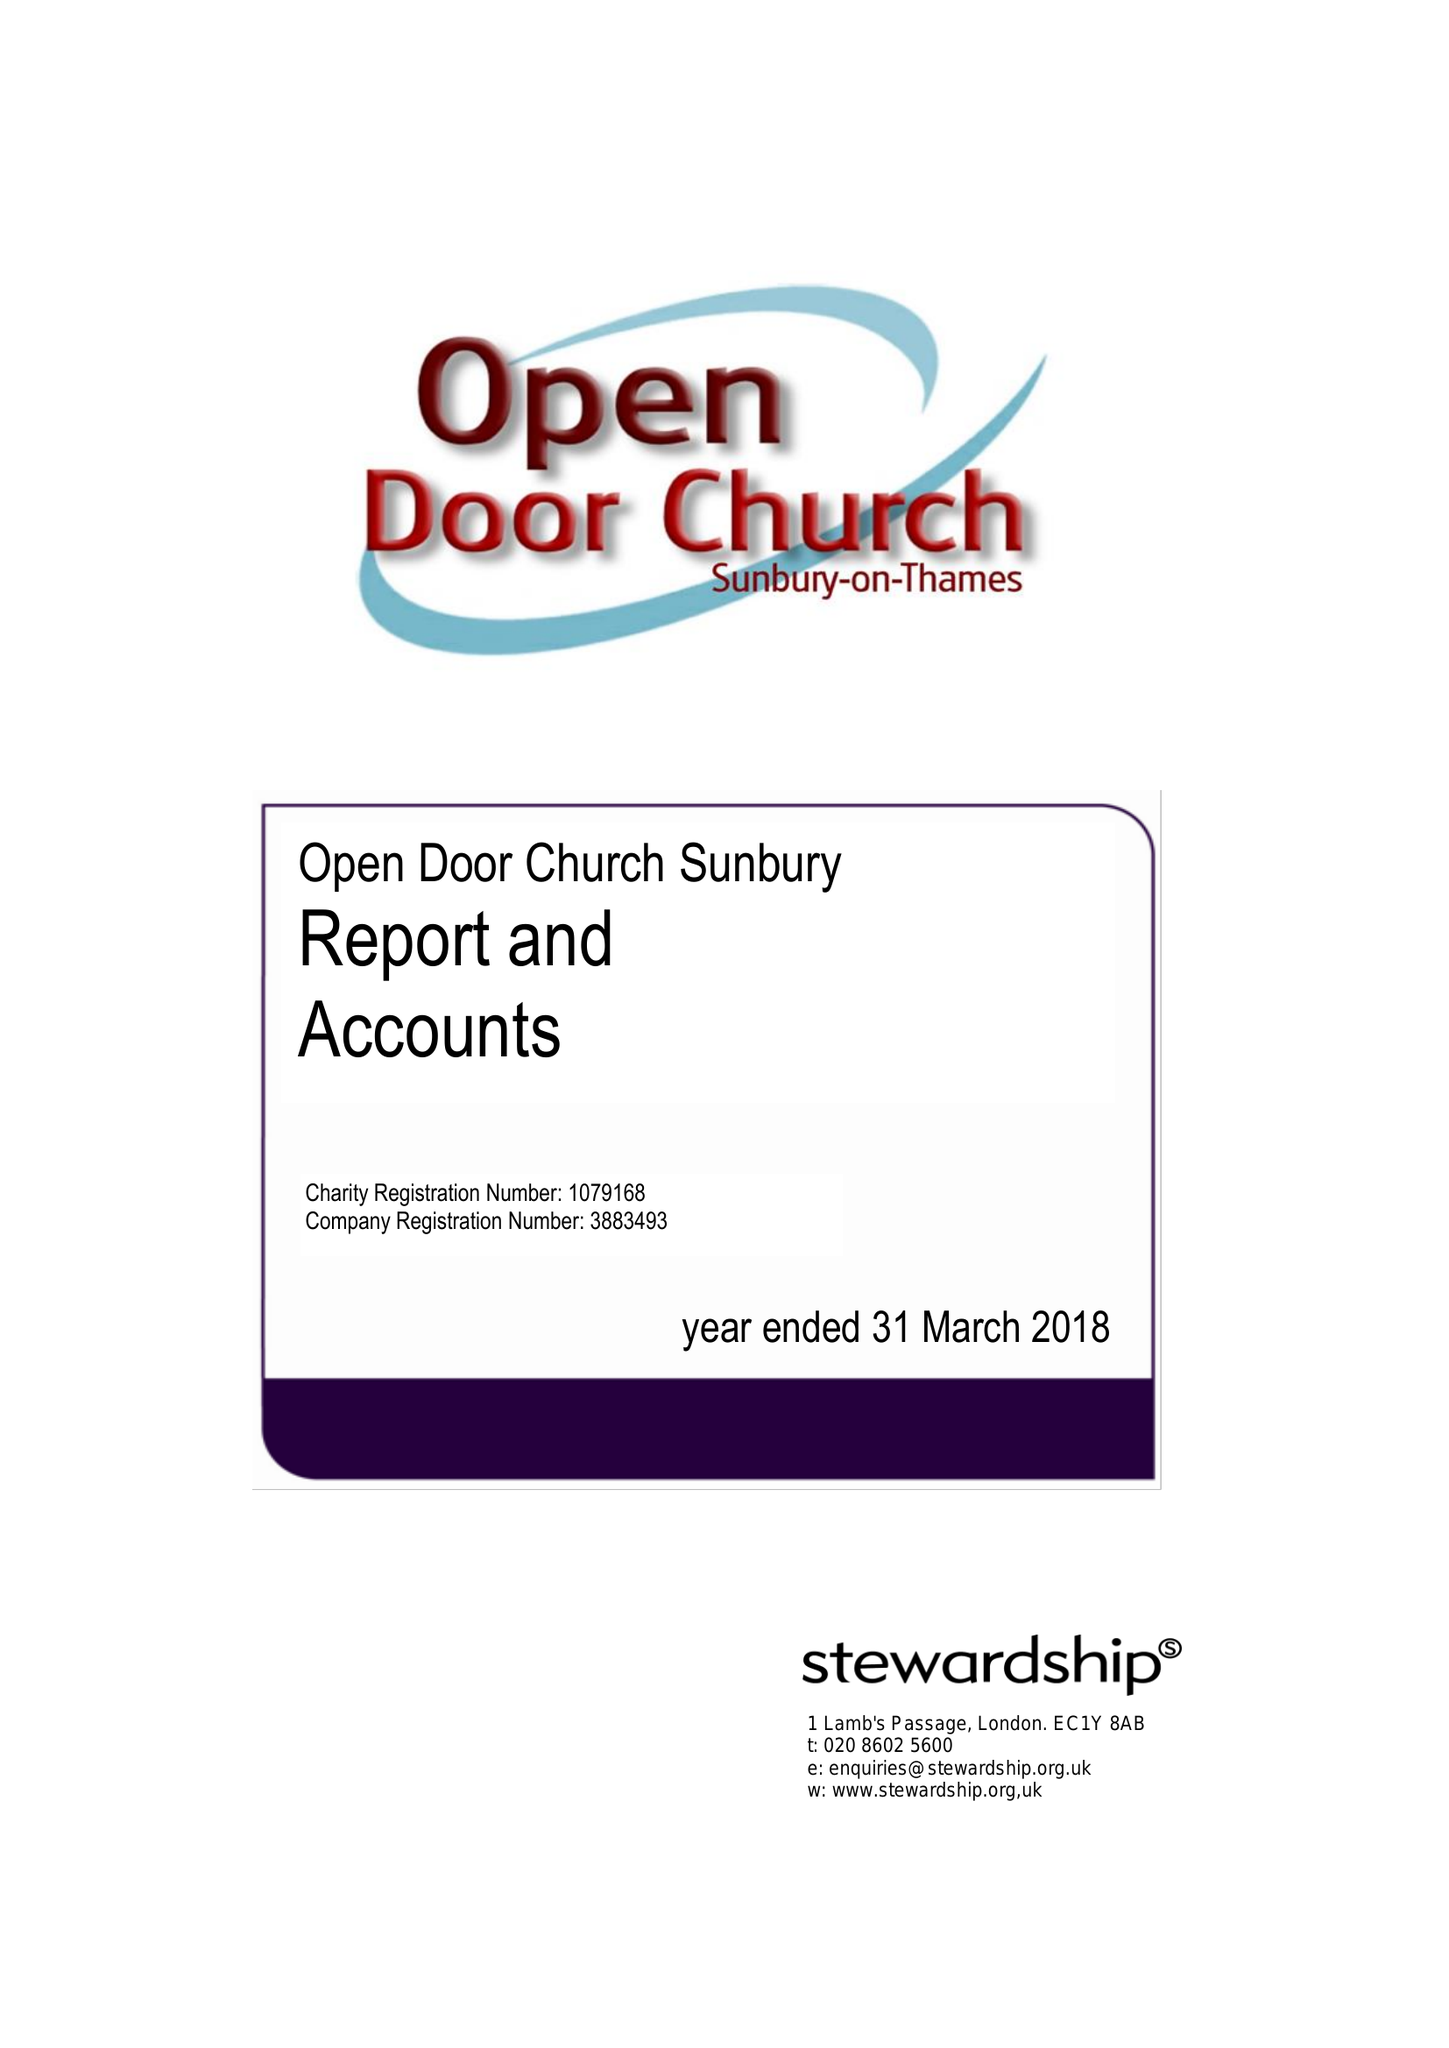What is the value for the spending_annually_in_british_pounds?
Answer the question using a single word or phrase. 170700.00 